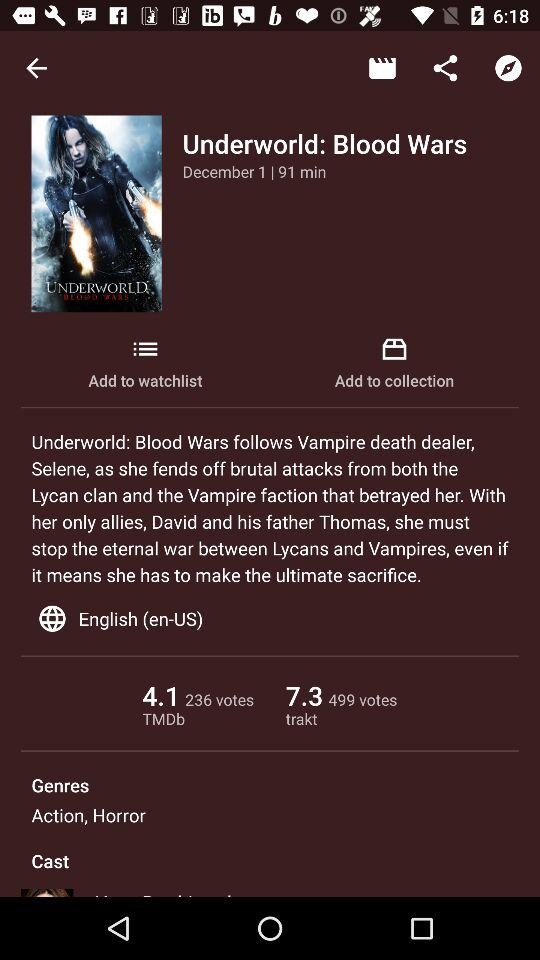What is the duration? The duration is 91 minutes. 